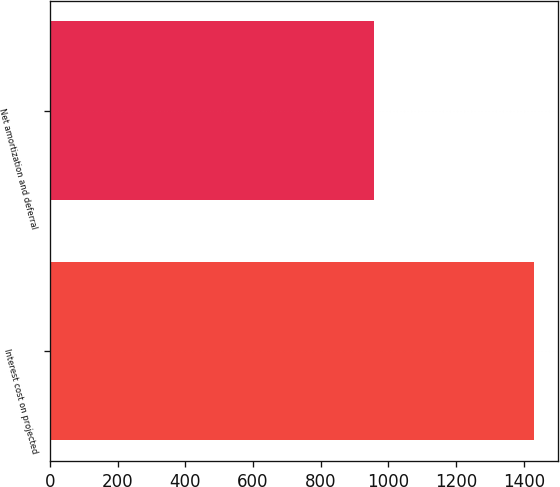<chart> <loc_0><loc_0><loc_500><loc_500><bar_chart><fcel>Interest cost on projected<fcel>Net amortization and deferral<nl><fcel>1431<fcel>958<nl></chart> 